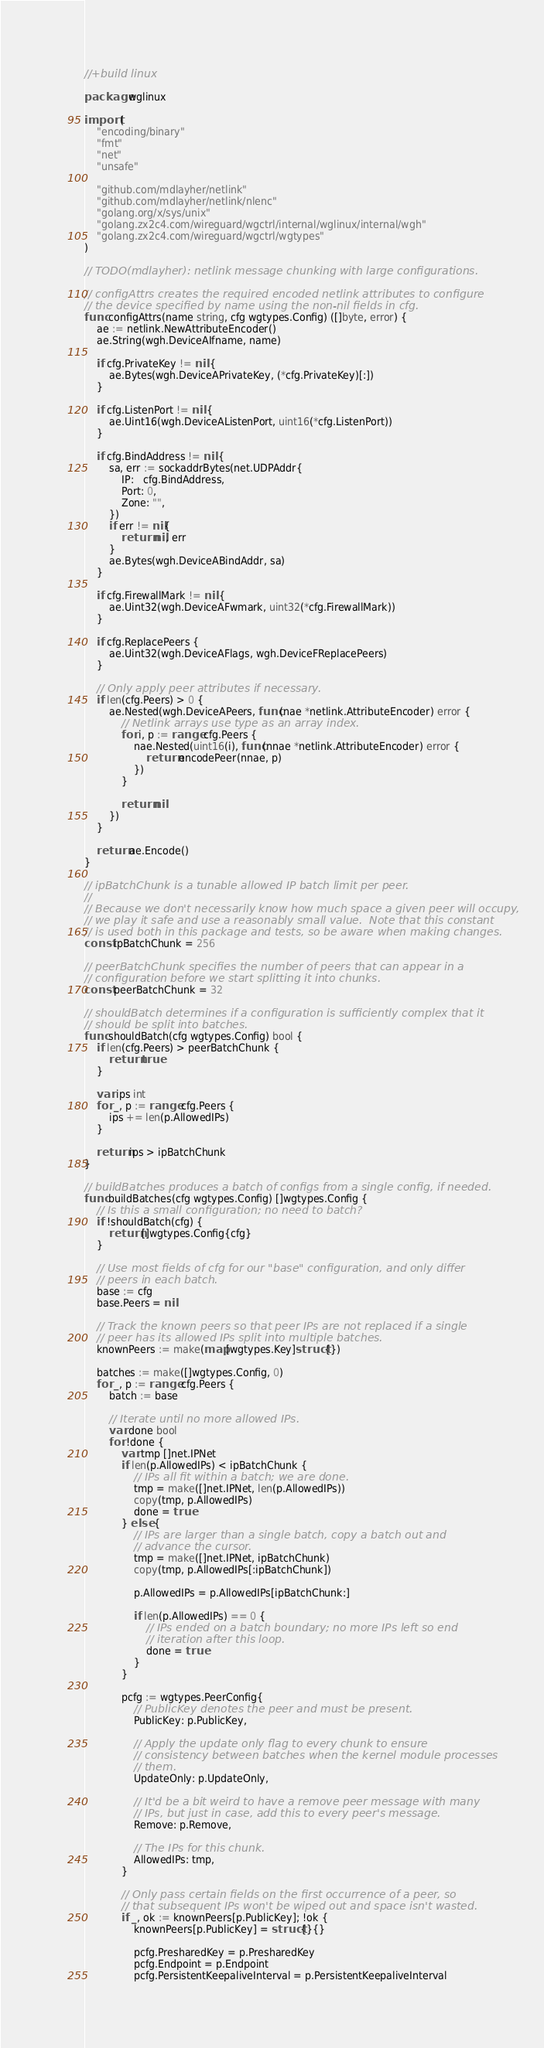Convert code to text. <code><loc_0><loc_0><loc_500><loc_500><_Go_>//+build linux

package wglinux

import (
	"encoding/binary"
	"fmt"
	"net"
	"unsafe"

	"github.com/mdlayher/netlink"
	"github.com/mdlayher/netlink/nlenc"
	"golang.org/x/sys/unix"
	"golang.zx2c4.com/wireguard/wgctrl/internal/wglinux/internal/wgh"
	"golang.zx2c4.com/wireguard/wgctrl/wgtypes"
)

// TODO(mdlayher): netlink message chunking with large configurations.

// configAttrs creates the required encoded netlink attributes to configure
// the device specified by name using the non-nil fields in cfg.
func configAttrs(name string, cfg wgtypes.Config) ([]byte, error) {
	ae := netlink.NewAttributeEncoder()
	ae.String(wgh.DeviceAIfname, name)

	if cfg.PrivateKey != nil {
		ae.Bytes(wgh.DeviceAPrivateKey, (*cfg.PrivateKey)[:])
	}

	if cfg.ListenPort != nil {
		ae.Uint16(wgh.DeviceAListenPort, uint16(*cfg.ListenPort))
	}

	if cfg.BindAddress != nil {
		sa, err := sockaddrBytes(net.UDPAddr{
			IP:   cfg.BindAddress,
			Port: 0,
			Zone: "",
		})
		if err != nil{
			return nil, err
		}
		ae.Bytes(wgh.DeviceABindAddr, sa)
	}

	if cfg.FirewallMark != nil {
		ae.Uint32(wgh.DeviceAFwmark, uint32(*cfg.FirewallMark))
	}

	if cfg.ReplacePeers {
		ae.Uint32(wgh.DeviceAFlags, wgh.DeviceFReplacePeers)
	}

	// Only apply peer attributes if necessary.
	if len(cfg.Peers) > 0 {
		ae.Nested(wgh.DeviceAPeers, func(nae *netlink.AttributeEncoder) error {
			// Netlink arrays use type as an array index.
			for i, p := range cfg.Peers {
				nae.Nested(uint16(i), func(nnae *netlink.AttributeEncoder) error {
					return encodePeer(nnae, p)
				})
			}

			return nil
		})
	}

	return ae.Encode()
}

// ipBatchChunk is a tunable allowed IP batch limit per peer.
//
// Because we don't necessarily know how much space a given peer will occupy,
// we play it safe and use a reasonably small value.  Note that this constant
// is used both in this package and tests, so be aware when making changes.
const ipBatchChunk = 256

// peerBatchChunk specifies the number of peers that can appear in a
// configuration before we start splitting it into chunks.
const peerBatchChunk = 32

// shouldBatch determines if a configuration is sufficiently complex that it
// should be split into batches.
func shouldBatch(cfg wgtypes.Config) bool {
	if len(cfg.Peers) > peerBatchChunk {
		return true
	}

	var ips int
	for _, p := range cfg.Peers {
		ips += len(p.AllowedIPs)
	}

	return ips > ipBatchChunk
}

// buildBatches produces a batch of configs from a single config, if needed.
func buildBatches(cfg wgtypes.Config) []wgtypes.Config {
	// Is this a small configuration; no need to batch?
	if !shouldBatch(cfg) {
		return []wgtypes.Config{cfg}
	}

	// Use most fields of cfg for our "base" configuration, and only differ
	// peers in each batch.
	base := cfg
	base.Peers = nil

	// Track the known peers so that peer IPs are not replaced if a single
	// peer has its allowed IPs split into multiple batches.
	knownPeers := make(map[wgtypes.Key]struct{})

	batches := make([]wgtypes.Config, 0)
	for _, p := range cfg.Peers {
		batch := base

		// Iterate until no more allowed IPs.
		var done bool
		for !done {
			var tmp []net.IPNet
			if len(p.AllowedIPs) < ipBatchChunk {
				// IPs all fit within a batch; we are done.
				tmp = make([]net.IPNet, len(p.AllowedIPs))
				copy(tmp, p.AllowedIPs)
				done = true
			} else {
				// IPs are larger than a single batch, copy a batch out and
				// advance the cursor.
				tmp = make([]net.IPNet, ipBatchChunk)
				copy(tmp, p.AllowedIPs[:ipBatchChunk])

				p.AllowedIPs = p.AllowedIPs[ipBatchChunk:]

				if len(p.AllowedIPs) == 0 {
					// IPs ended on a batch boundary; no more IPs left so end
					// iteration after this loop.
					done = true
				}
			}

			pcfg := wgtypes.PeerConfig{
				// PublicKey denotes the peer and must be present.
				PublicKey: p.PublicKey,

				// Apply the update only flag to every chunk to ensure
				// consistency between batches when the kernel module processes
				// them.
				UpdateOnly: p.UpdateOnly,

				// It'd be a bit weird to have a remove peer message with many
				// IPs, but just in case, add this to every peer's message.
				Remove: p.Remove,

				// The IPs for this chunk.
				AllowedIPs: tmp,
			}

			// Only pass certain fields on the first occurrence of a peer, so
			// that subsequent IPs won't be wiped out and space isn't wasted.
			if _, ok := knownPeers[p.PublicKey]; !ok {
				knownPeers[p.PublicKey] = struct{}{}

				pcfg.PresharedKey = p.PresharedKey
				pcfg.Endpoint = p.Endpoint
				pcfg.PersistentKeepaliveInterval = p.PersistentKeepaliveInterval
</code> 